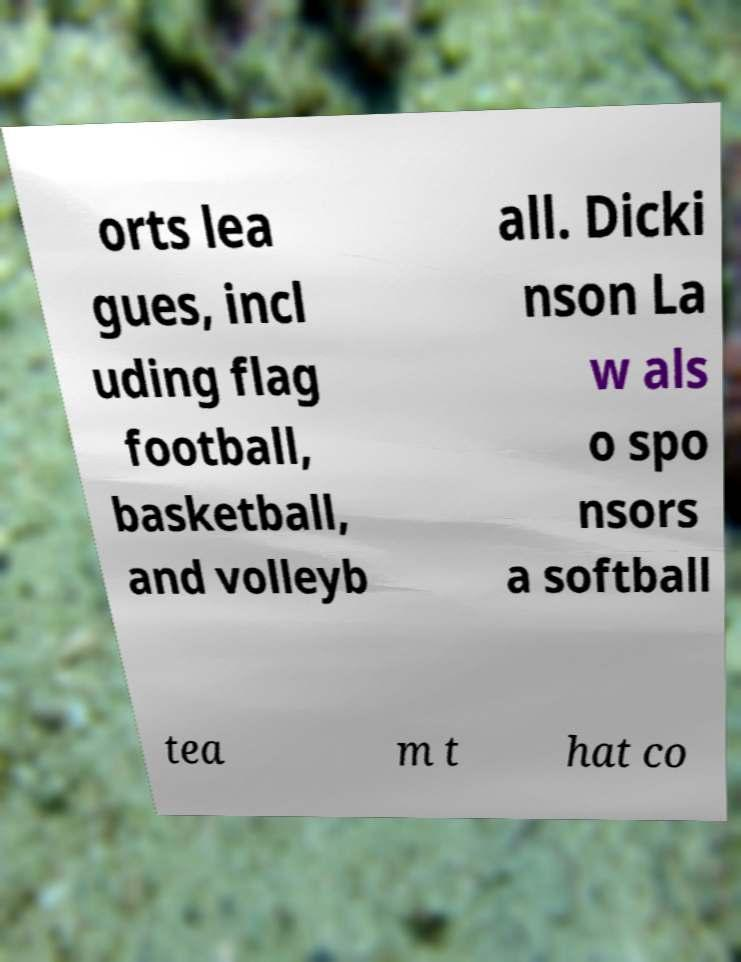For documentation purposes, I need the text within this image transcribed. Could you provide that? orts lea gues, incl uding flag football, basketball, and volleyb all. Dicki nson La w als o spo nsors a softball tea m t hat co 